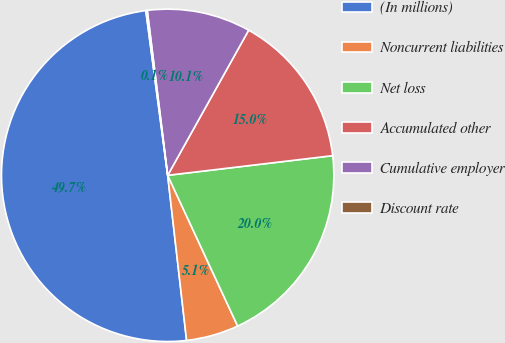Convert chart to OTSL. <chart><loc_0><loc_0><loc_500><loc_500><pie_chart><fcel>(In millions)<fcel>Noncurrent liabilities<fcel>Net loss<fcel>Accumulated other<fcel>Cumulative employer<fcel>Discount rate<nl><fcel>49.71%<fcel>5.1%<fcel>19.97%<fcel>15.01%<fcel>10.06%<fcel>0.14%<nl></chart> 